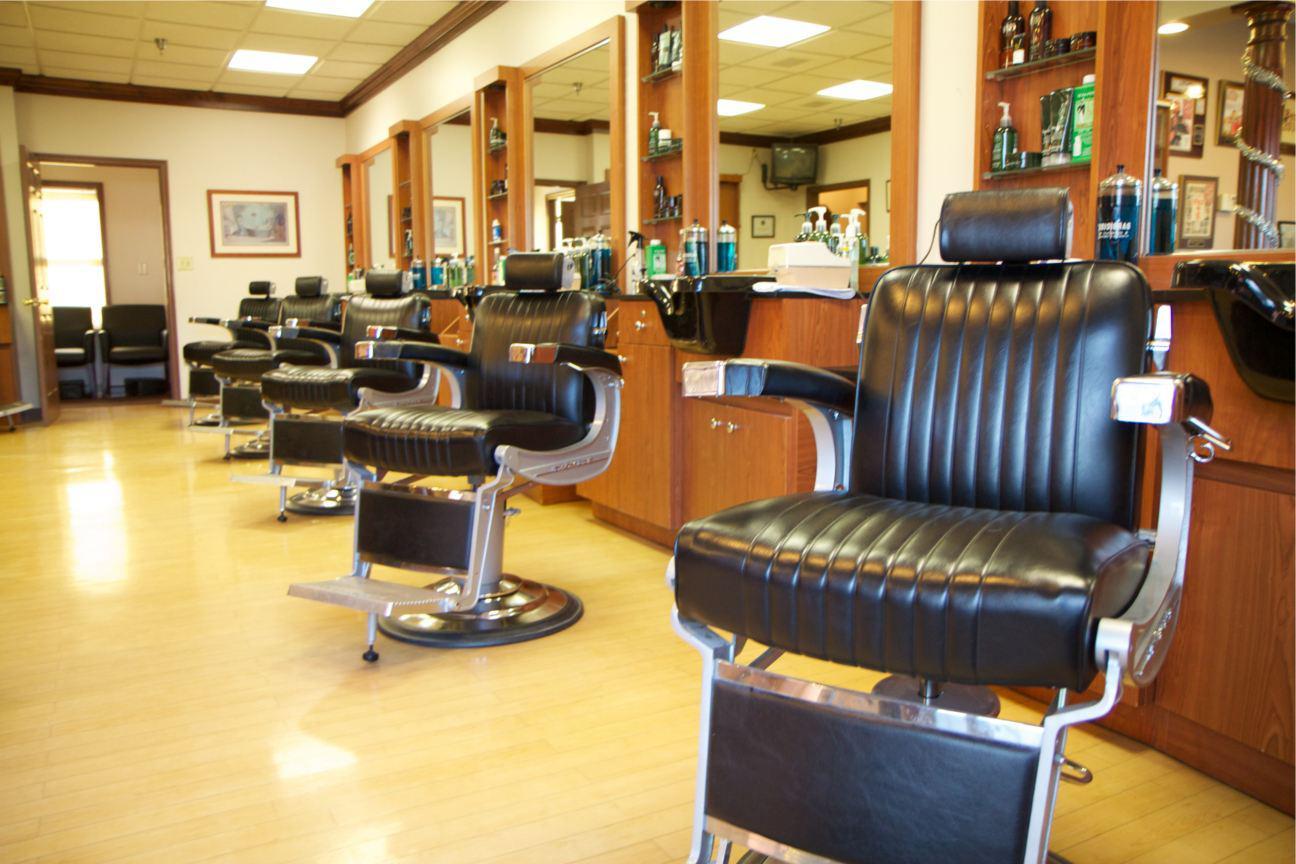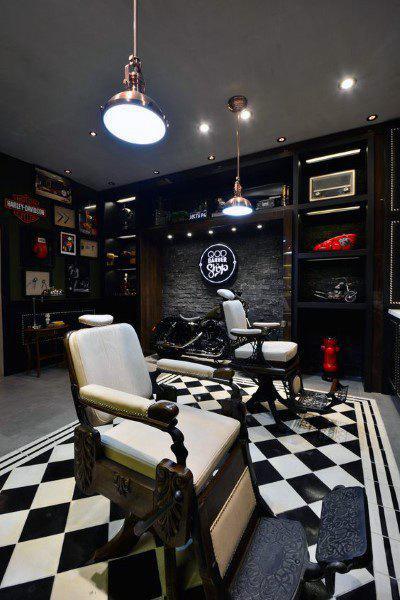The first image is the image on the left, the second image is the image on the right. For the images shown, is this caption "A row of five black barber chairs faces the camera in one image." true? Answer yes or no. Yes. The first image is the image on the left, the second image is the image on the right. Given the left and right images, does the statement "At least one image shows the front side of a barber chair." hold true? Answer yes or no. Yes. 